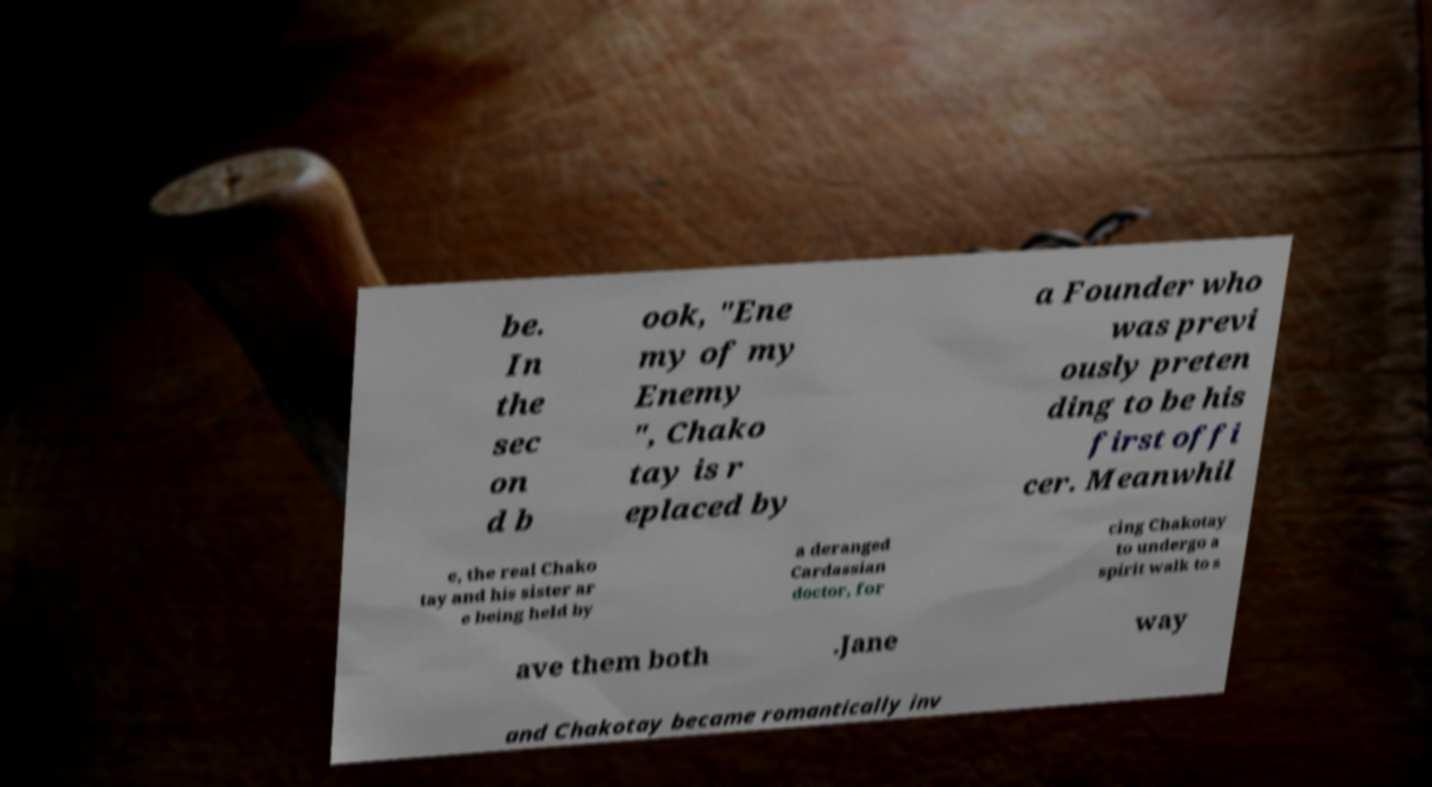Please identify and transcribe the text found in this image. be. In the sec on d b ook, "Ene my of my Enemy ", Chako tay is r eplaced by a Founder who was previ ously preten ding to be his first offi cer. Meanwhil e, the real Chako tay and his sister ar e being held by a deranged Cardassian doctor, for cing Chakotay to undergo a spirit walk to s ave them both .Jane way and Chakotay became romantically inv 